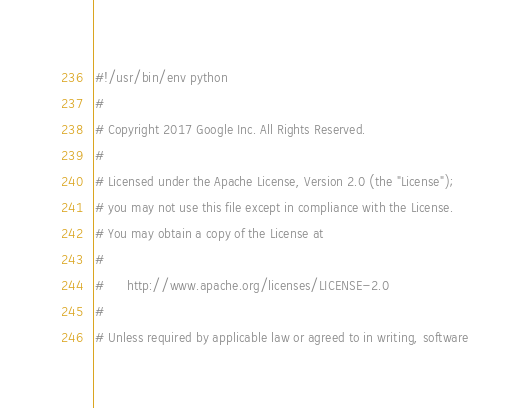Convert code to text. <code><loc_0><loc_0><loc_500><loc_500><_Python_>#!/usr/bin/env python
#
# Copyright 2017 Google Inc. All Rights Reserved.
#
# Licensed under the Apache License, Version 2.0 (the "License");
# you may not use this file except in compliance with the License.
# You may obtain a copy of the License at
#
#      http://www.apache.org/licenses/LICENSE-2.0
#
# Unless required by applicable law or agreed to in writing, software</code> 